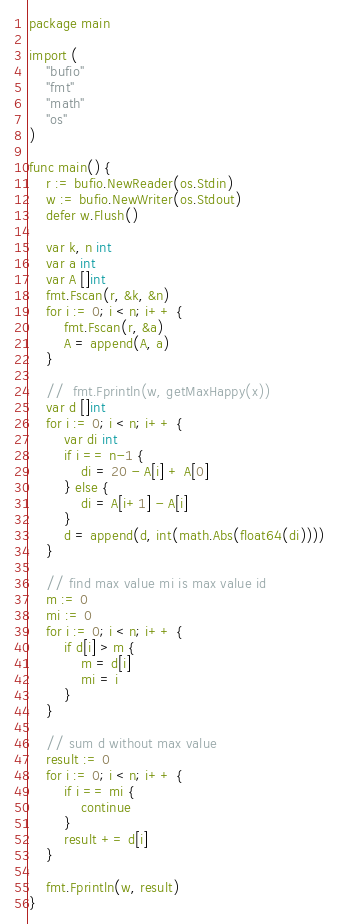<code> <loc_0><loc_0><loc_500><loc_500><_Go_>package main

import (
	"bufio"
	"fmt"
	"math"
	"os"
)

func main() {
	r := bufio.NewReader(os.Stdin)
	w := bufio.NewWriter(os.Stdout)
	defer w.Flush()

	var k, n int
	var a int
	var A []int
	fmt.Fscan(r, &k, &n)
	for i := 0; i < n; i++ {
		fmt.Fscan(r, &a)
		A = append(A, a)
	}

	//	fmt.Fprintln(w, getMaxHappy(x))
	var d []int
	for i := 0; i < n; i++ {
		var di int
		if i == n-1 {
			di = 20 - A[i] + A[0]
		} else {
			di = A[i+1] - A[i]
		}
		d = append(d, int(math.Abs(float64(di))))
	}

	// find max value mi is max value id
	m := 0
	mi := 0
	for i := 0; i < n; i++ {
		if d[i] > m {
			m = d[i]
			mi = i
		}
	}

	// sum d without max value
	result := 0
	for i := 0; i < n; i++ {
		if i == mi {
			continue
		}
		result += d[i]
	}

	fmt.Fprintln(w, result)
}</code> 